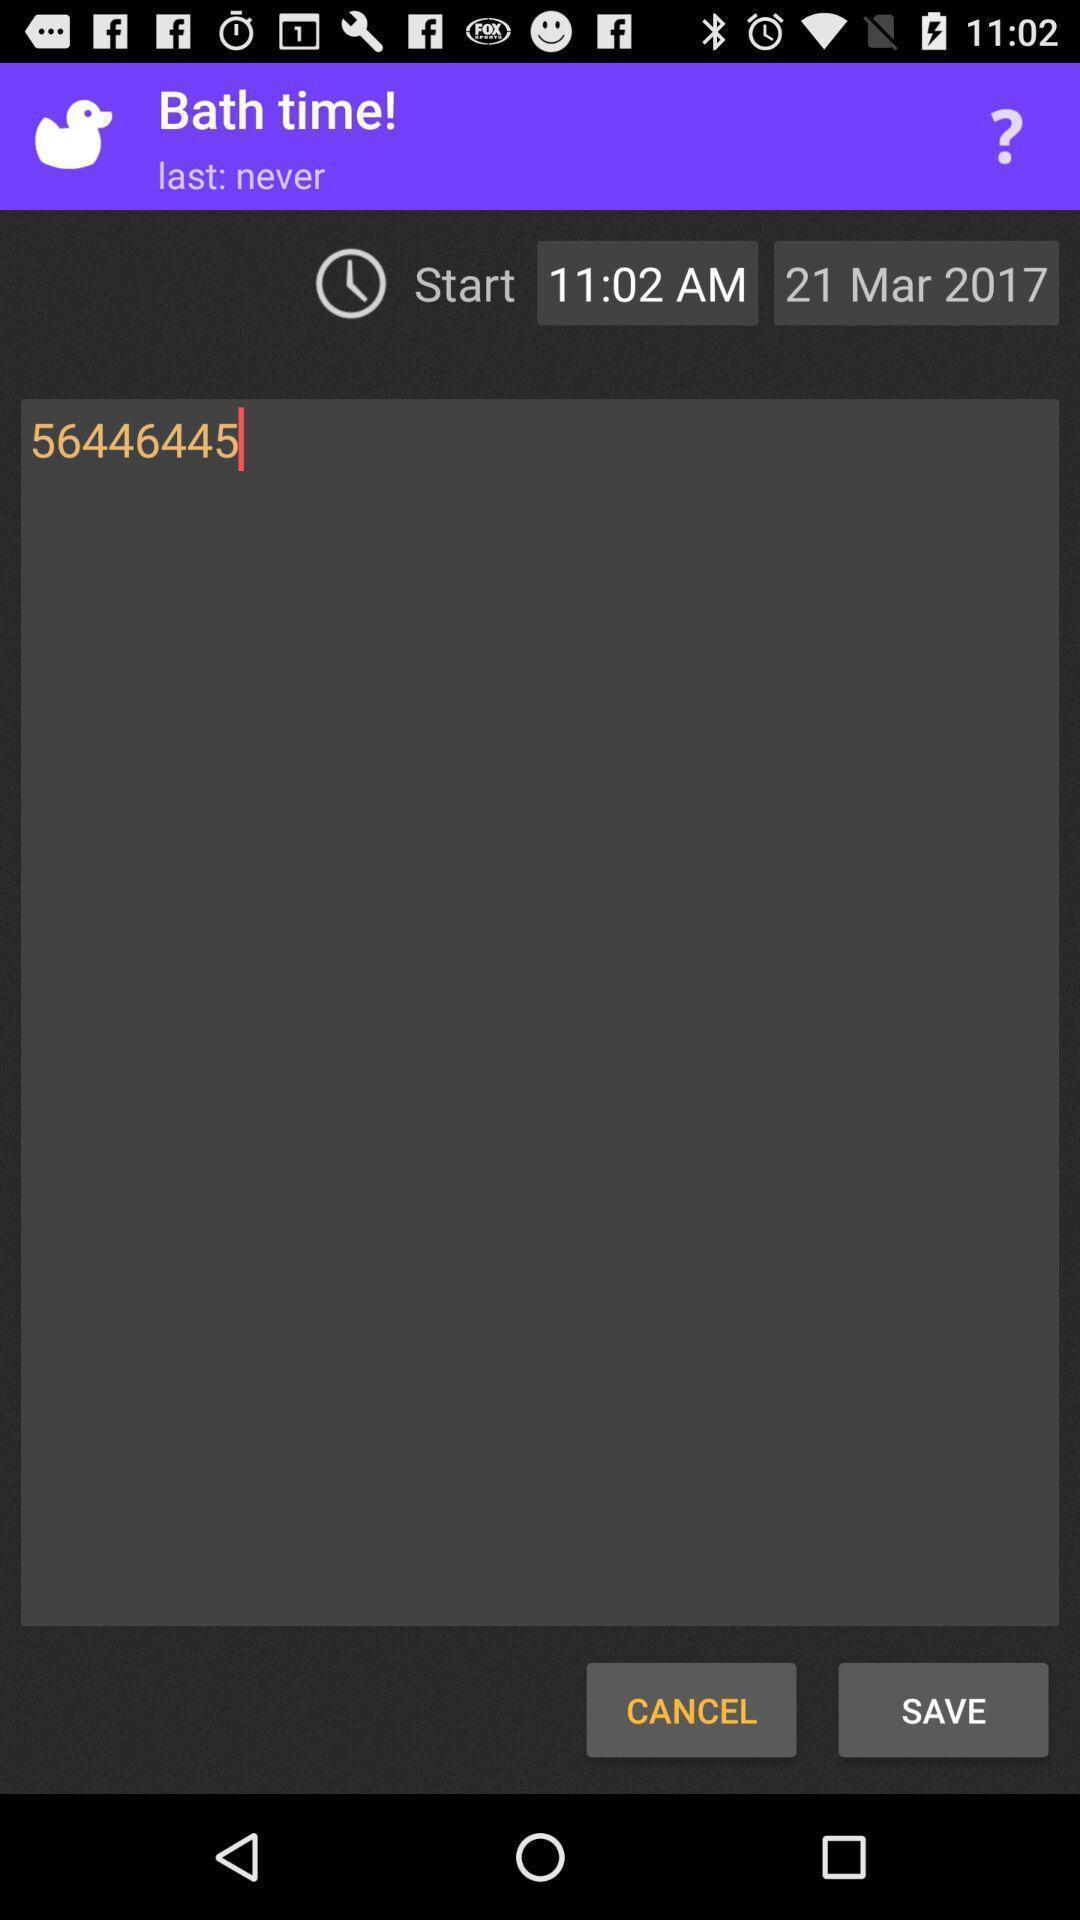What can you discern from this picture? Screen shows bath time details. 